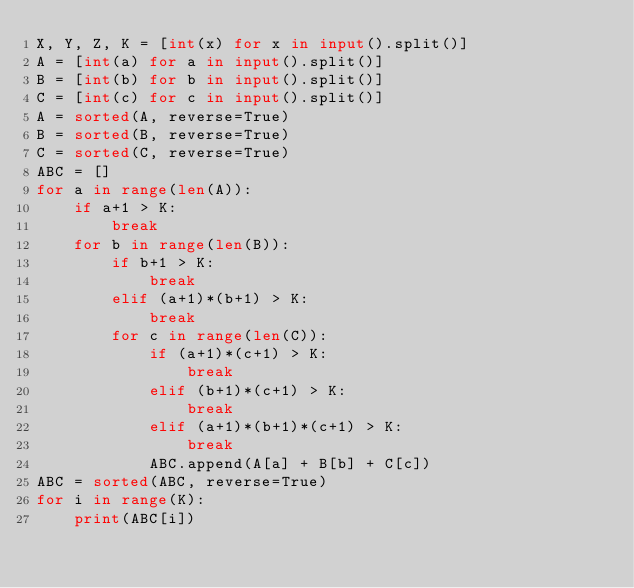<code> <loc_0><loc_0><loc_500><loc_500><_Python_>X, Y, Z, K = [int(x) for x in input().split()]
A = [int(a) for a in input().split()]
B = [int(b) for b in input().split()]
C = [int(c) for c in input().split()]
A = sorted(A, reverse=True)
B = sorted(B, reverse=True)
C = sorted(C, reverse=True)
ABC = []
for a in range(len(A)):
    if a+1 > K:
        break
    for b in range(len(B)):
        if b+1 > K:
            break
        elif (a+1)*(b+1) > K:
            break
        for c in range(len(C)):
            if (a+1)*(c+1) > K:
                break
            elif (b+1)*(c+1) > K:
                break
            elif (a+1)*(b+1)*(c+1) > K:
                break
            ABC.append(A[a] + B[b] + C[c])
ABC = sorted(ABC, reverse=True)
for i in range(K):
    print(ABC[i])</code> 